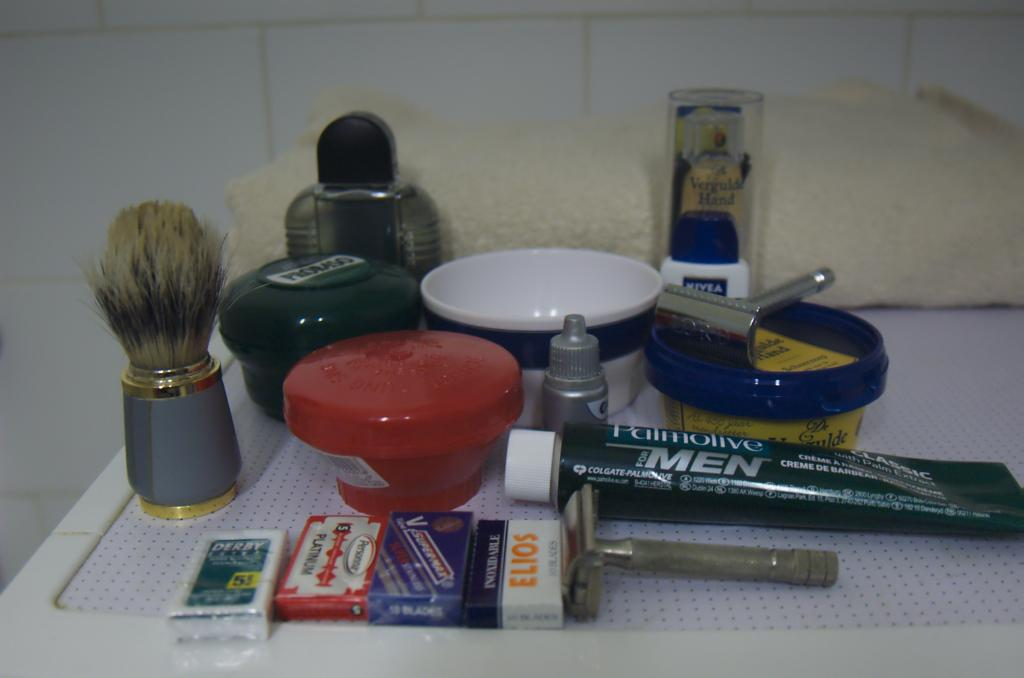<image>
Provide a brief description of the given image. Several cleaning products are on a shelf including Palmolive toothpaste for men. 